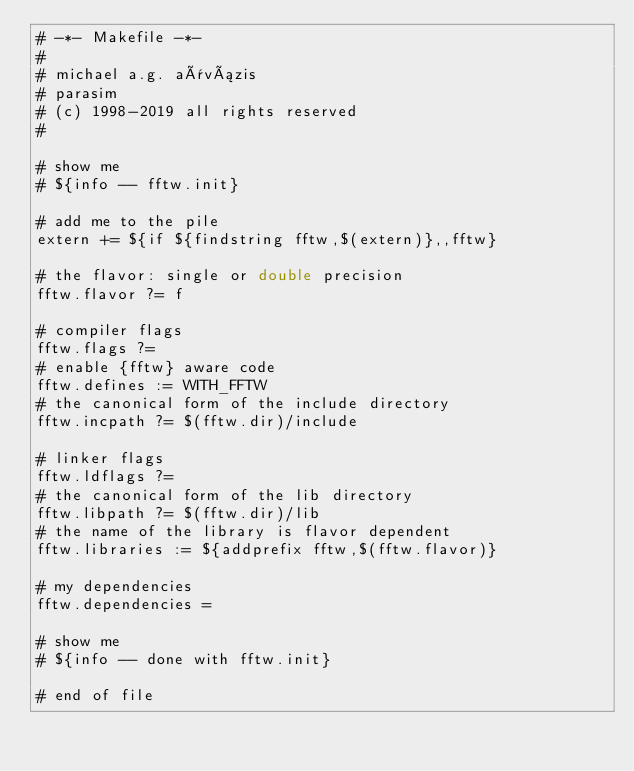<code> <loc_0><loc_0><loc_500><loc_500><_ObjectiveC_># -*- Makefile -*-
#
# michael a.g. aïvázis
# parasim
# (c) 1998-2019 all rights reserved
#

# show me
# ${info -- fftw.init}

# add me to the pile
extern += ${if ${findstring fftw,$(extern)},,fftw}

# the flavor: single or double precision
fftw.flavor ?= f

# compiler flags
fftw.flags ?=
# enable {fftw} aware code
fftw.defines := WITH_FFTW
# the canonical form of the include directory
fftw.incpath ?= $(fftw.dir)/include

# linker flags
fftw.ldflags ?=
# the canonical form of the lib directory
fftw.libpath ?= $(fftw.dir)/lib
# the name of the library is flavor dependent
fftw.libraries := ${addprefix fftw,$(fftw.flavor)}

# my dependencies
fftw.dependencies =

# show me
# ${info -- done with fftw.init}

# end of file
</code> 